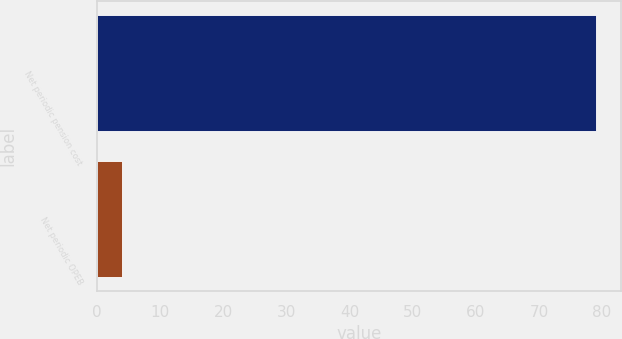Convert chart. <chart><loc_0><loc_0><loc_500><loc_500><bar_chart><fcel>Net periodic pension cost<fcel>Net periodic OPEB<nl><fcel>79<fcel>4<nl></chart> 